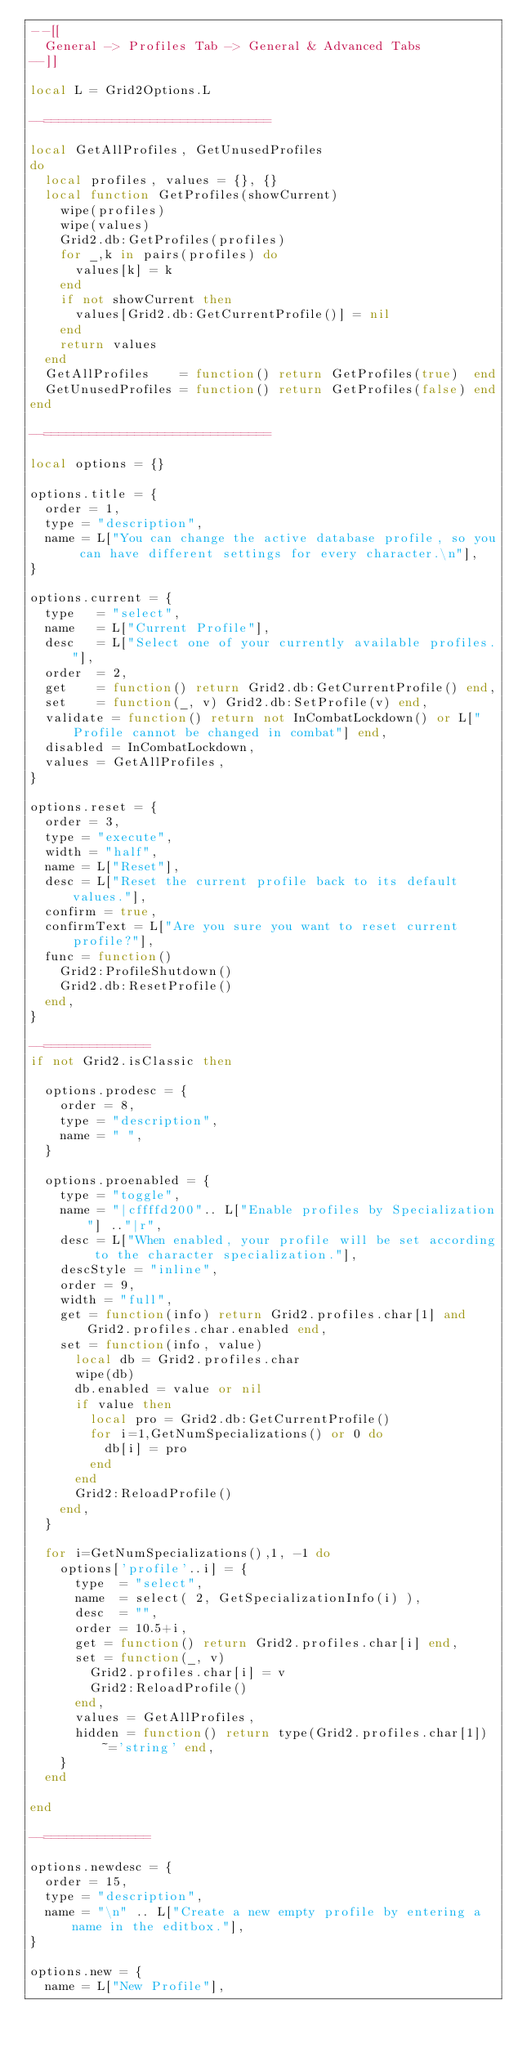Convert code to text. <code><loc_0><loc_0><loc_500><loc_500><_Lua_>--[[
	General -> Profiles Tab -> General & Advanced Tabs
--]]

local L = Grid2Options.L

--==============================

local GetAllProfiles, GetUnusedProfiles
do
	local profiles, values = {}, {}
	local function GetProfiles(showCurrent)
		wipe(profiles)
		wipe(values)
		Grid2.db:GetProfiles(profiles)
		for _,k in pairs(profiles) do
			values[k] = k
		end
		if not showCurrent then
			values[Grid2.db:GetCurrentProfile()] = nil
		end
		return values
	end
	GetAllProfiles    = function() return GetProfiles(true)  end
	GetUnusedProfiles = function() return GetProfiles(false) end
end

--==============================

local options = {}

options.title = {
	order = 1,
	type = "description",
	name = L["You can change the active database profile, so you can have different settings for every character.\n"],
}

options.current = {
	type   = "select",
	name   = L["Current Profile"],
	desc   = L["Select one of your currently available profiles."],
	order  = 2,
	get    = function() return Grid2.db:GetCurrentProfile() end,
	set    = function(_, v) Grid2.db:SetProfile(v) end,
	validate = function() return not InCombatLockdown() or L["Profile cannot be changed in combat"] end,
	disabled = InCombatLockdown,
	values = GetAllProfiles,
}

options.reset = {
	order = 3,
	type = "execute",
	width = "half",
	name = L["Reset"],
	desc = L["Reset the current profile back to its default values."],
	confirm = true,
	confirmText = L["Are you sure you want to reset current profile?"],
	func = function()
		Grid2:ProfileShutdown()
		Grid2.db:ResetProfile()
	end,
}

--==============
if not Grid2.isClassic then

	options.prodesc = {
		order = 8,
		type = "description",
		name = " ",
	}

	options.proenabled = {
		type = "toggle",
		name = "|cffffd200".. L["Enable profiles by Specialization"] .."|r",
		desc = L["When enabled, your profile will be set according to the character specialization."],
		descStyle = "inline",
		order = 9,
		width = "full",
		get = function(info) return Grid2.profiles.char[1] and Grid2.profiles.char.enabled end,
		set = function(info, value)
			local db = Grid2.profiles.char
			wipe(db)
			db.enabled = value or nil
			if value then
				local pro = Grid2.db:GetCurrentProfile()
				for i=1,GetNumSpecializations() or 0 do
					db[i] = pro
				end
			end
			Grid2:ReloadProfile()
		end,
	}

	for i=GetNumSpecializations(),1, -1 do
		options['profile'..i] = {
			type  = "select",
			name  = select( 2, GetSpecializationInfo(i) ),
			desc  = "",
			order = 10.5+i,
			get = function() return Grid2.profiles.char[i] end,
			set = function(_, v)
				Grid2.profiles.char[i] = v
				Grid2:ReloadProfile()
			end,
			values = GetAllProfiles,
			hidden = function() return type(Grid2.profiles.char[1])~='string' end,
		}
	end

end

--==============

options.newdesc = {
	order = 15,
	type = "description",
	name = "\n" .. L["Create a new empty profile by entering a name in the editbox."],
}

options.new = {
	name = L["New Profile"],</code> 